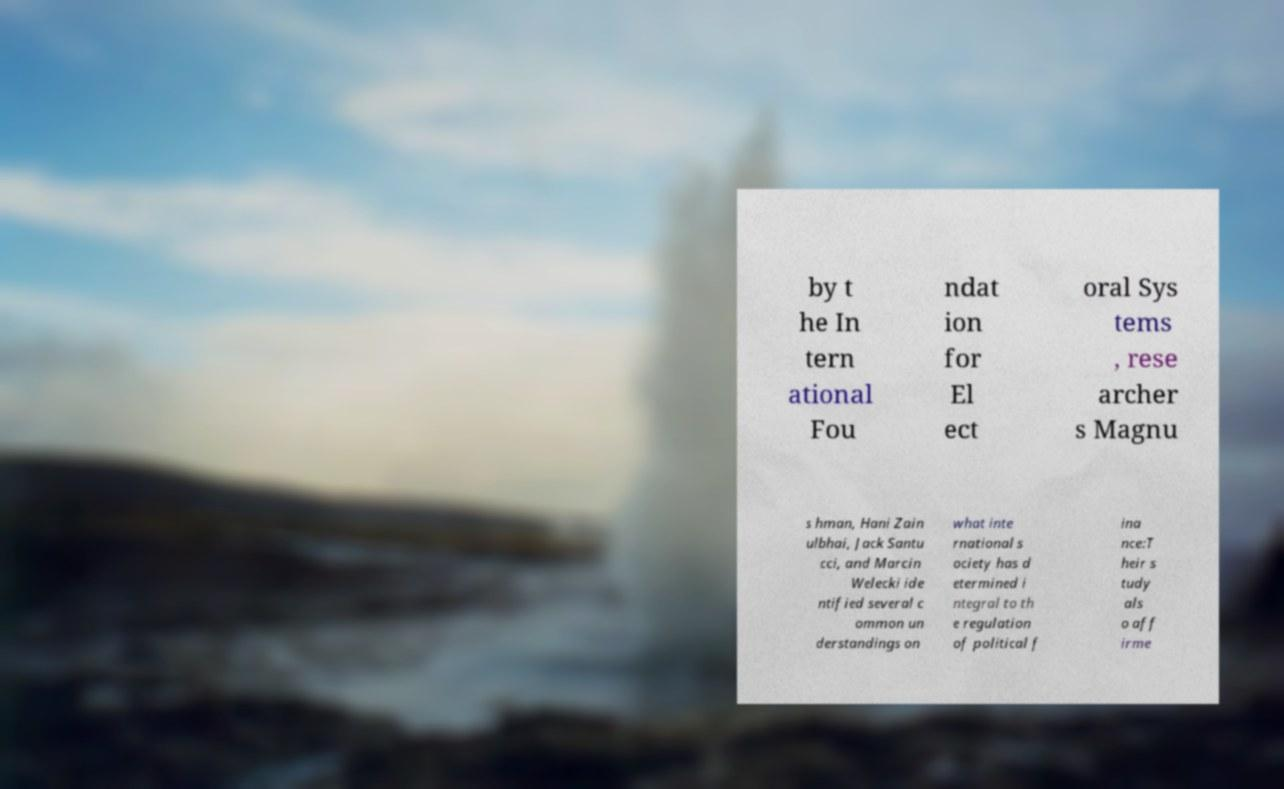Could you assist in decoding the text presented in this image and type it out clearly? by t he In tern ational Fou ndat ion for El ect oral Sys tems , rese archer s Magnu s hman, Hani Zain ulbhai, Jack Santu cci, and Marcin Welecki ide ntified several c ommon un derstandings on what inte rnational s ociety has d etermined i ntegral to th e regulation of political f ina nce:T heir s tudy als o aff irme 